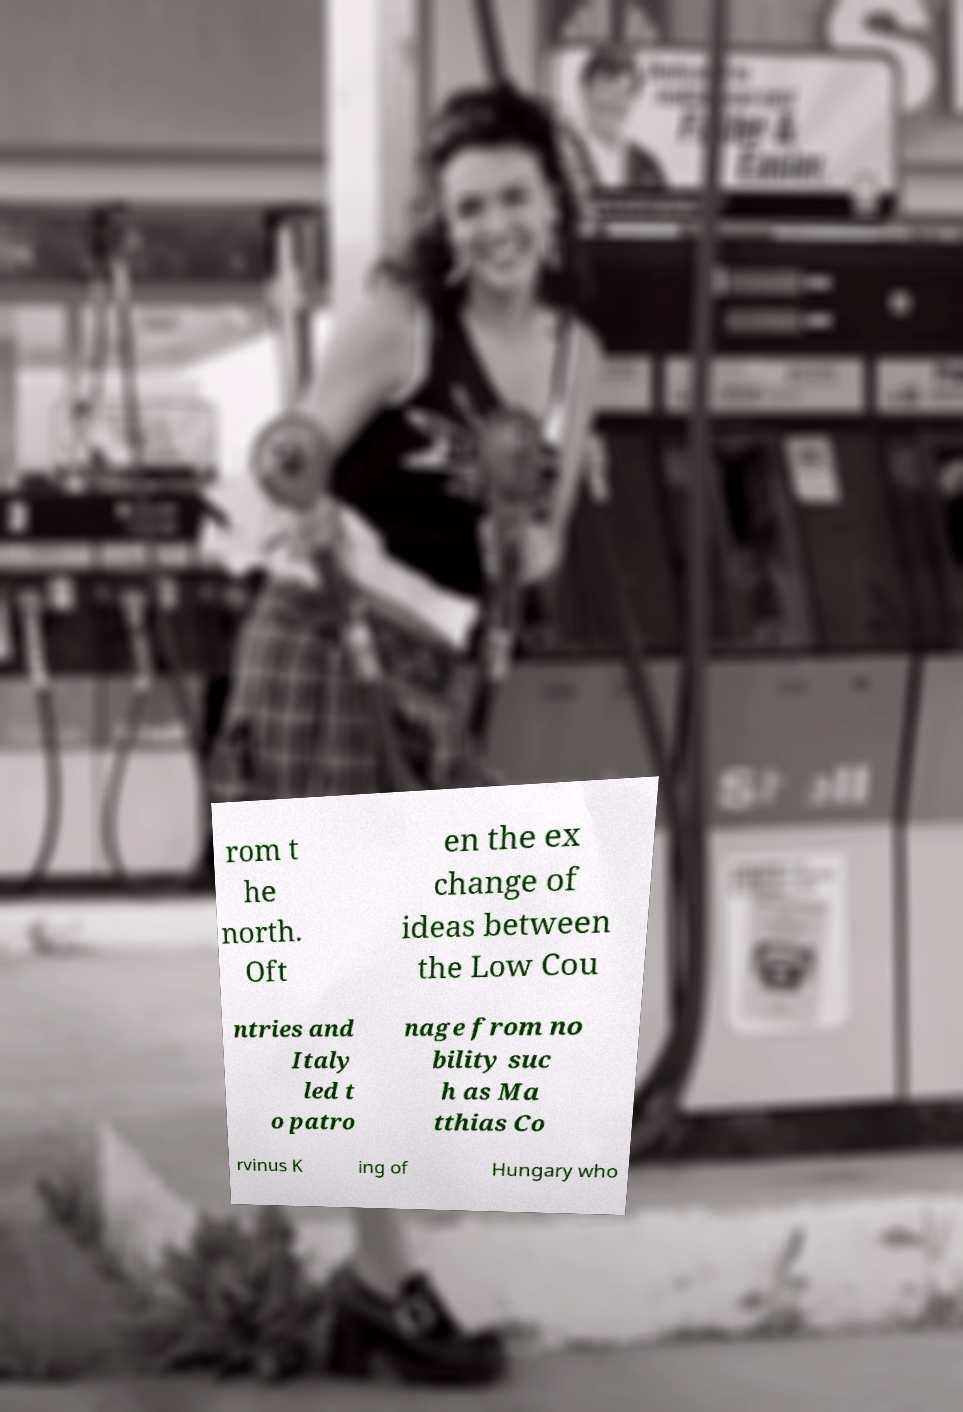Could you assist in decoding the text presented in this image and type it out clearly? rom t he north. Oft en the ex change of ideas between the Low Cou ntries and Italy led t o patro nage from no bility suc h as Ma tthias Co rvinus K ing of Hungary who 